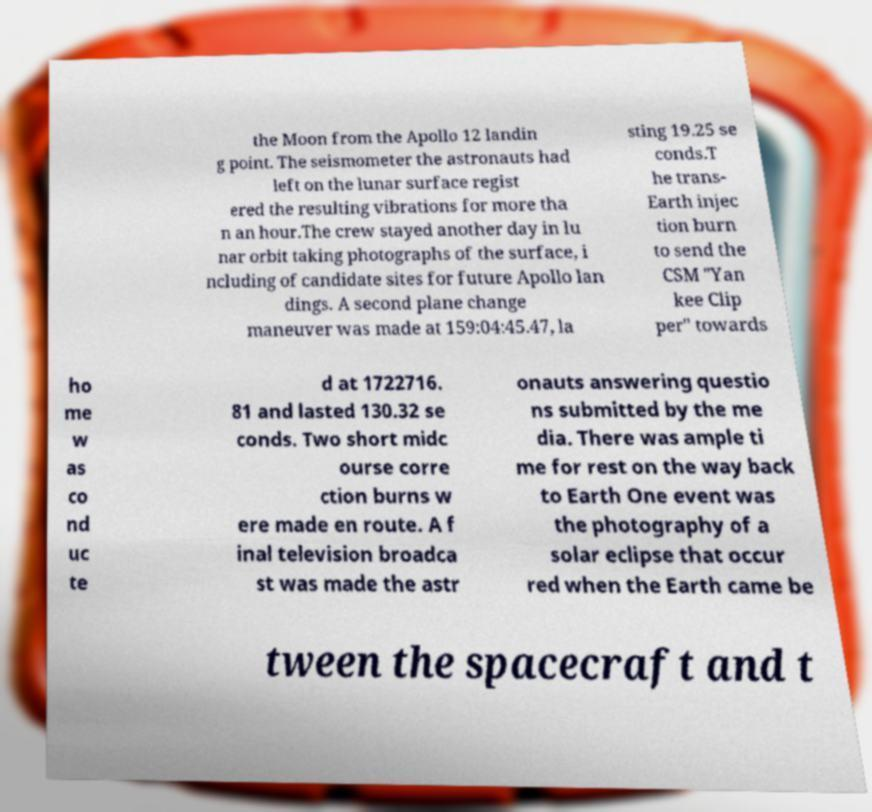Can you read and provide the text displayed in the image?This photo seems to have some interesting text. Can you extract and type it out for me? the Moon from the Apollo 12 landin g point. The seismometer the astronauts had left on the lunar surface regist ered the resulting vibrations for more tha n an hour.The crew stayed another day in lu nar orbit taking photographs of the surface, i ncluding of candidate sites for future Apollo lan dings. A second plane change maneuver was made at 159:04:45.47, la sting 19.25 se conds.T he trans- Earth injec tion burn to send the CSM "Yan kee Clip per" towards ho me w as co nd uc te d at 1722716. 81 and lasted 130.32 se conds. Two short midc ourse corre ction burns w ere made en route. A f inal television broadca st was made the astr onauts answering questio ns submitted by the me dia. There was ample ti me for rest on the way back to Earth One event was the photography of a solar eclipse that occur red when the Earth came be tween the spacecraft and t 